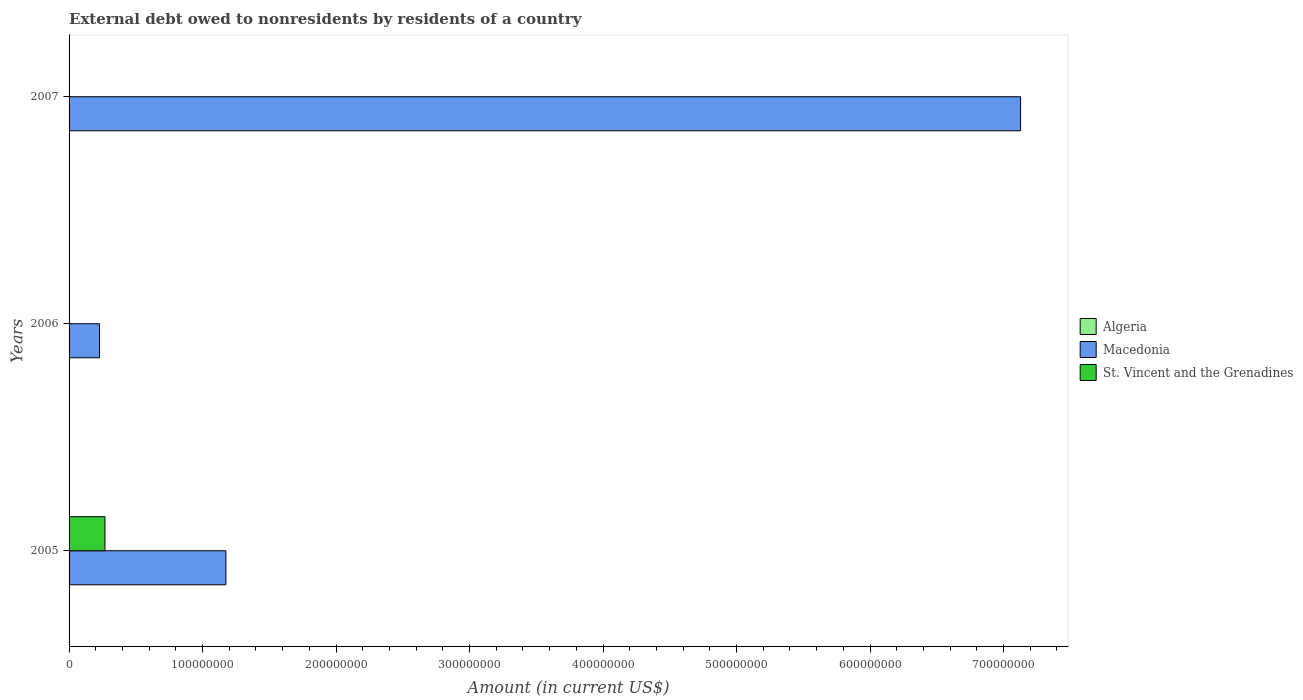Are the number of bars per tick equal to the number of legend labels?
Your answer should be very brief. No. Are the number of bars on each tick of the Y-axis equal?
Your answer should be compact. No. How many bars are there on the 3rd tick from the top?
Ensure brevity in your answer.  2. How many bars are there on the 2nd tick from the bottom?
Keep it short and to the point. 1. In how many cases, is the number of bars for a given year not equal to the number of legend labels?
Ensure brevity in your answer.  3. Across all years, what is the maximum external debt owed by residents in Macedonia?
Your answer should be very brief. 7.13e+08. In which year was the external debt owed by residents in Macedonia maximum?
Your answer should be very brief. 2007. What is the difference between the external debt owed by residents in Macedonia in 2006 and that in 2007?
Provide a succinct answer. -6.90e+08. What is the difference between the external debt owed by residents in Macedonia in 2005 and the external debt owed by residents in St. Vincent and the Grenadines in 2007?
Make the answer very short. 1.17e+08. In the year 2005, what is the difference between the external debt owed by residents in St. Vincent and the Grenadines and external debt owed by residents in Macedonia?
Your response must be concise. -9.06e+07. What is the ratio of the external debt owed by residents in Macedonia in 2005 to that in 2006?
Ensure brevity in your answer.  5.14. Is the external debt owed by residents in Macedonia in 2006 less than that in 2007?
Give a very brief answer. Yes. What is the difference between the highest and the lowest external debt owed by residents in Macedonia?
Give a very brief answer. 6.90e+08. In how many years, is the external debt owed by residents in Algeria greater than the average external debt owed by residents in Algeria taken over all years?
Your answer should be compact. 0. How many bars are there?
Your answer should be compact. 4. How many years are there in the graph?
Provide a succinct answer. 3. What is the difference between two consecutive major ticks on the X-axis?
Offer a terse response. 1.00e+08. Does the graph contain any zero values?
Ensure brevity in your answer.  Yes. How many legend labels are there?
Provide a short and direct response. 3. What is the title of the graph?
Your answer should be very brief. External debt owed to nonresidents by residents of a country. Does "Other small states" appear as one of the legend labels in the graph?
Your answer should be compact. No. What is the Amount (in current US$) in Algeria in 2005?
Offer a terse response. 0. What is the Amount (in current US$) of Macedonia in 2005?
Your response must be concise. 1.17e+08. What is the Amount (in current US$) of St. Vincent and the Grenadines in 2005?
Make the answer very short. 2.69e+07. What is the Amount (in current US$) in Macedonia in 2006?
Provide a short and direct response. 2.28e+07. What is the Amount (in current US$) of Macedonia in 2007?
Offer a very short reply. 7.13e+08. What is the Amount (in current US$) of St. Vincent and the Grenadines in 2007?
Offer a very short reply. 0. Across all years, what is the maximum Amount (in current US$) in Macedonia?
Your response must be concise. 7.13e+08. Across all years, what is the maximum Amount (in current US$) of St. Vincent and the Grenadines?
Offer a very short reply. 2.69e+07. Across all years, what is the minimum Amount (in current US$) of Macedonia?
Your answer should be compact. 2.28e+07. What is the total Amount (in current US$) in Algeria in the graph?
Offer a very short reply. 0. What is the total Amount (in current US$) of Macedonia in the graph?
Offer a very short reply. 8.53e+08. What is the total Amount (in current US$) of St. Vincent and the Grenadines in the graph?
Your response must be concise. 2.69e+07. What is the difference between the Amount (in current US$) of Macedonia in 2005 and that in 2006?
Provide a succinct answer. 9.46e+07. What is the difference between the Amount (in current US$) in Macedonia in 2005 and that in 2007?
Keep it short and to the point. -5.95e+08. What is the difference between the Amount (in current US$) of Macedonia in 2006 and that in 2007?
Give a very brief answer. -6.90e+08. What is the average Amount (in current US$) of Macedonia per year?
Make the answer very short. 2.84e+08. What is the average Amount (in current US$) of St. Vincent and the Grenadines per year?
Your answer should be compact. 8.96e+06. In the year 2005, what is the difference between the Amount (in current US$) of Macedonia and Amount (in current US$) of St. Vincent and the Grenadines?
Your answer should be compact. 9.06e+07. What is the ratio of the Amount (in current US$) of Macedonia in 2005 to that in 2006?
Keep it short and to the point. 5.14. What is the ratio of the Amount (in current US$) in Macedonia in 2005 to that in 2007?
Offer a terse response. 0.16. What is the ratio of the Amount (in current US$) of Macedonia in 2006 to that in 2007?
Offer a terse response. 0.03. What is the difference between the highest and the second highest Amount (in current US$) in Macedonia?
Keep it short and to the point. 5.95e+08. What is the difference between the highest and the lowest Amount (in current US$) of Macedonia?
Your response must be concise. 6.90e+08. What is the difference between the highest and the lowest Amount (in current US$) of St. Vincent and the Grenadines?
Your answer should be very brief. 2.69e+07. 